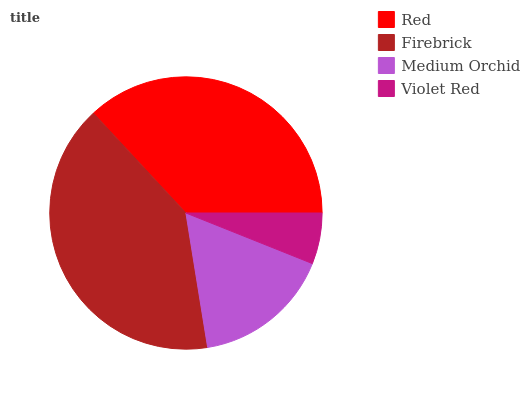Is Violet Red the minimum?
Answer yes or no. Yes. Is Firebrick the maximum?
Answer yes or no. Yes. Is Medium Orchid the minimum?
Answer yes or no. No. Is Medium Orchid the maximum?
Answer yes or no. No. Is Firebrick greater than Medium Orchid?
Answer yes or no. Yes. Is Medium Orchid less than Firebrick?
Answer yes or no. Yes. Is Medium Orchid greater than Firebrick?
Answer yes or no. No. Is Firebrick less than Medium Orchid?
Answer yes or no. No. Is Red the high median?
Answer yes or no. Yes. Is Medium Orchid the low median?
Answer yes or no. Yes. Is Violet Red the high median?
Answer yes or no. No. Is Red the low median?
Answer yes or no. No. 